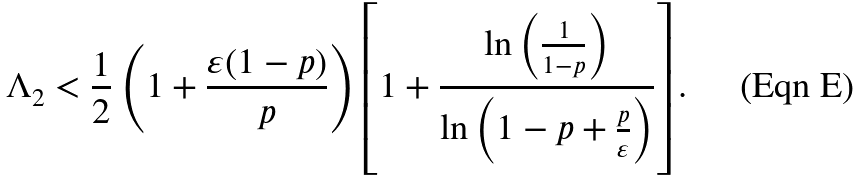<formula> <loc_0><loc_0><loc_500><loc_500>\Lambda _ { 2 } < \frac { 1 } { 2 } \left ( 1 + \frac { \varepsilon ( 1 - p ) } { p } \right ) \left [ 1 + \frac { \ln \left ( \frac { 1 } { 1 - p } \right ) } { \ln \left ( 1 - p + \frac { p } { \varepsilon } \right ) } \right ] .</formula> 